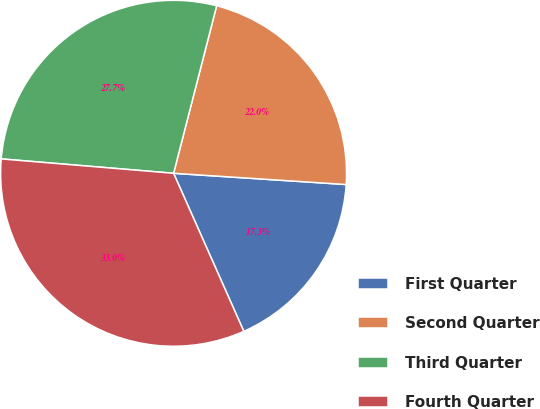<chart> <loc_0><loc_0><loc_500><loc_500><pie_chart><fcel>First Quarter<fcel>Second Quarter<fcel>Third Quarter<fcel>Fourth Quarter<nl><fcel>17.31%<fcel>22.03%<fcel>27.68%<fcel>32.98%<nl></chart> 